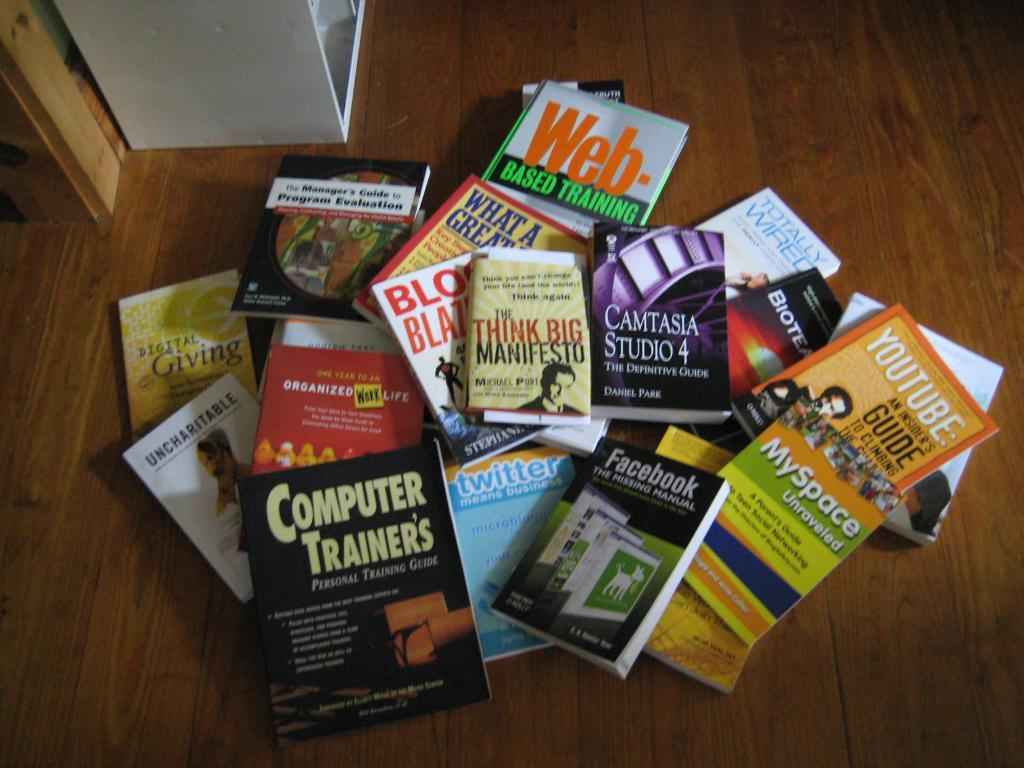<image>
Provide a brief description of the given image. A book titled " The Think Big Manfesto" by Michael Port. 